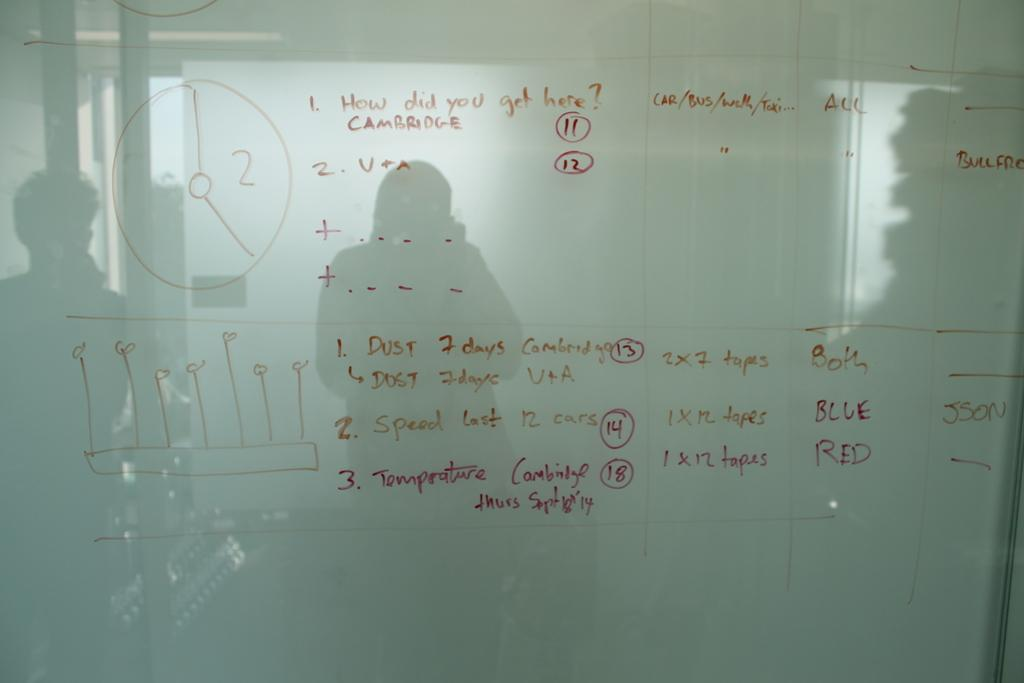What is the main object in the center of the image? There is a board in the center of the image. What can be seen on the board? There is text on the board. Can you describe anything else visible in the image? There is a reflection of some persons in the image. What type of bean is being used to construct the board in the image? There is no bean mentioned or visible in the image; the board is made of a different material. 